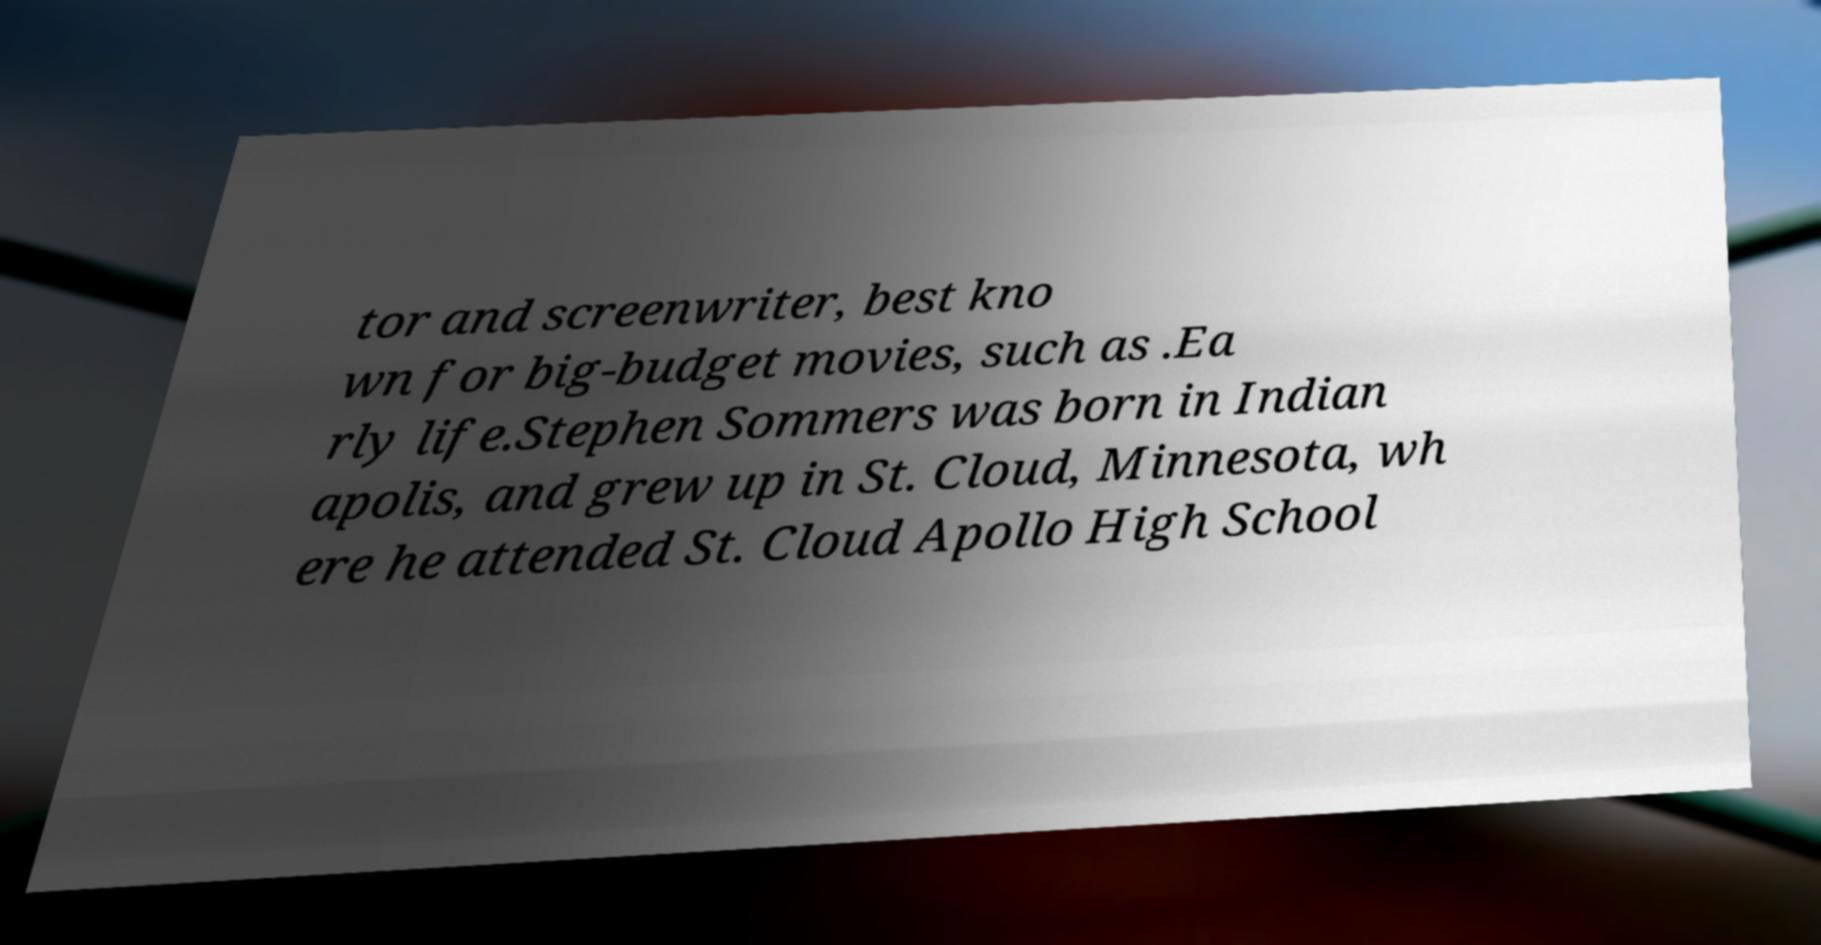Please read and relay the text visible in this image. What does it say? tor and screenwriter, best kno wn for big-budget movies, such as .Ea rly life.Stephen Sommers was born in Indian apolis, and grew up in St. Cloud, Minnesota, wh ere he attended St. Cloud Apollo High School 